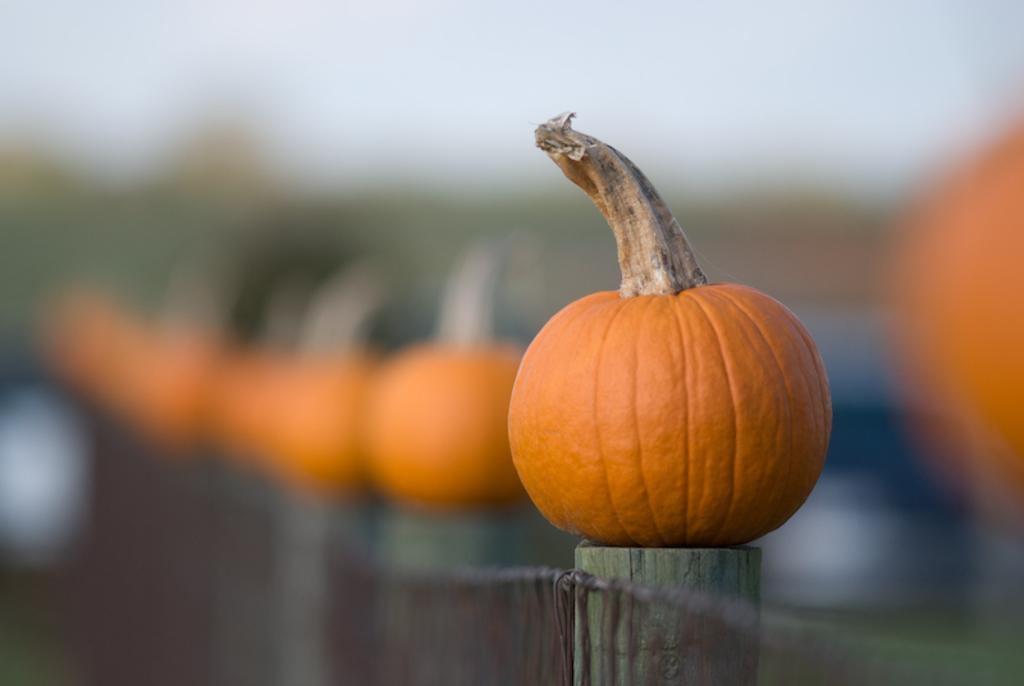What is the main subject in the foreground of the image? There is a pumpkin in the foreground of the image. How is the background of the image depicted? The background of the pumpkin is blurred. What type of son can be seen playing with the pumpkin in the image? There is no son present in the image; it only features a pumpkin with a blurred background. 